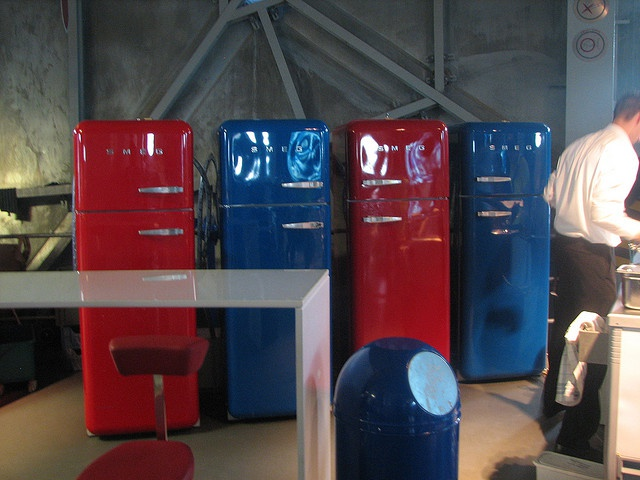Describe the objects in this image and their specific colors. I can see refrigerator in black, maroon, and gray tones, refrigerator in black, maroon, brown, and purple tones, refrigerator in black, navy, blue, and darkblue tones, refrigerator in black, navy, and blue tones, and people in black, white, gray, and tan tones in this image. 